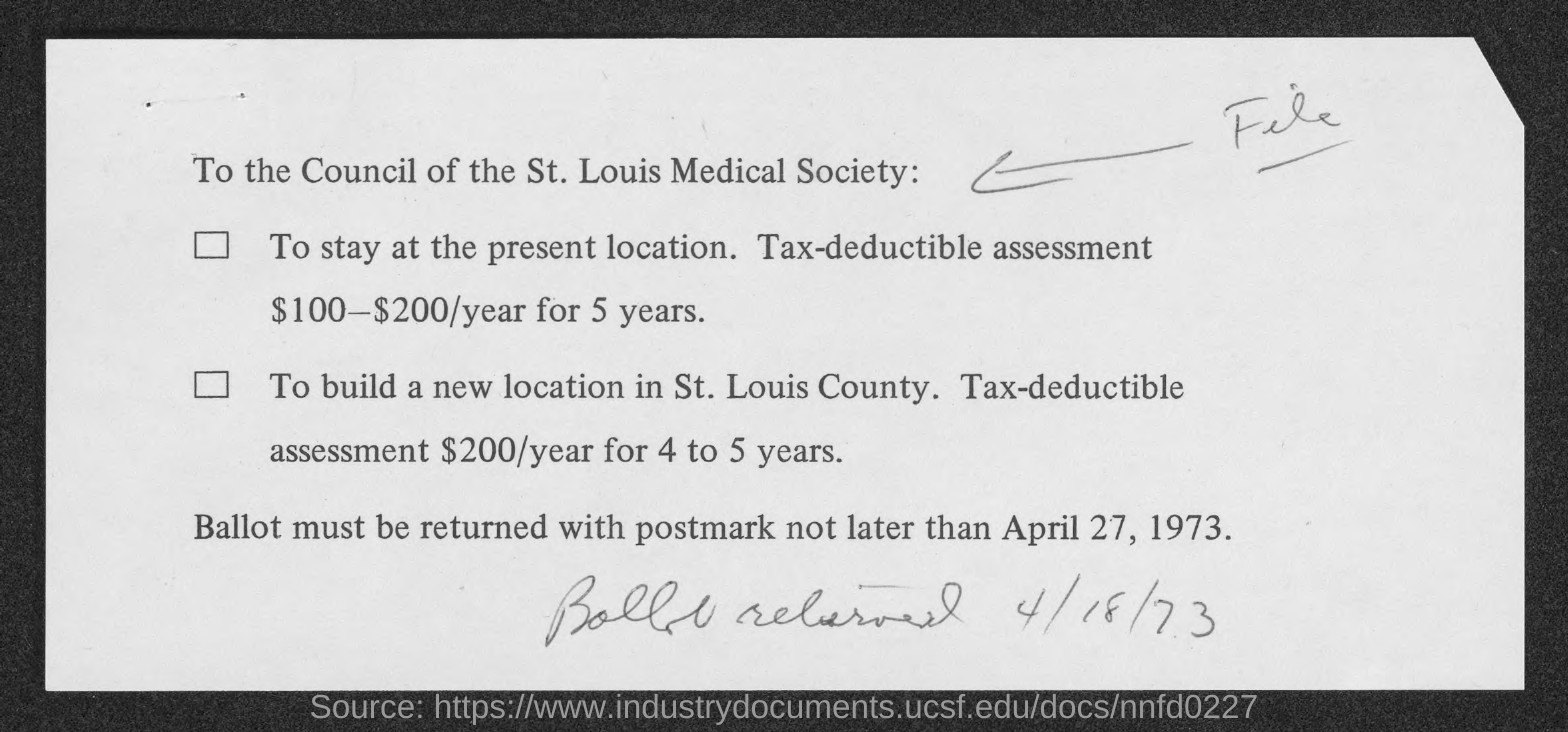Indicate a few pertinent items in this graphic. The ballot must be returned with a postmark not later than April 27, 1973, as stated on the notice. 